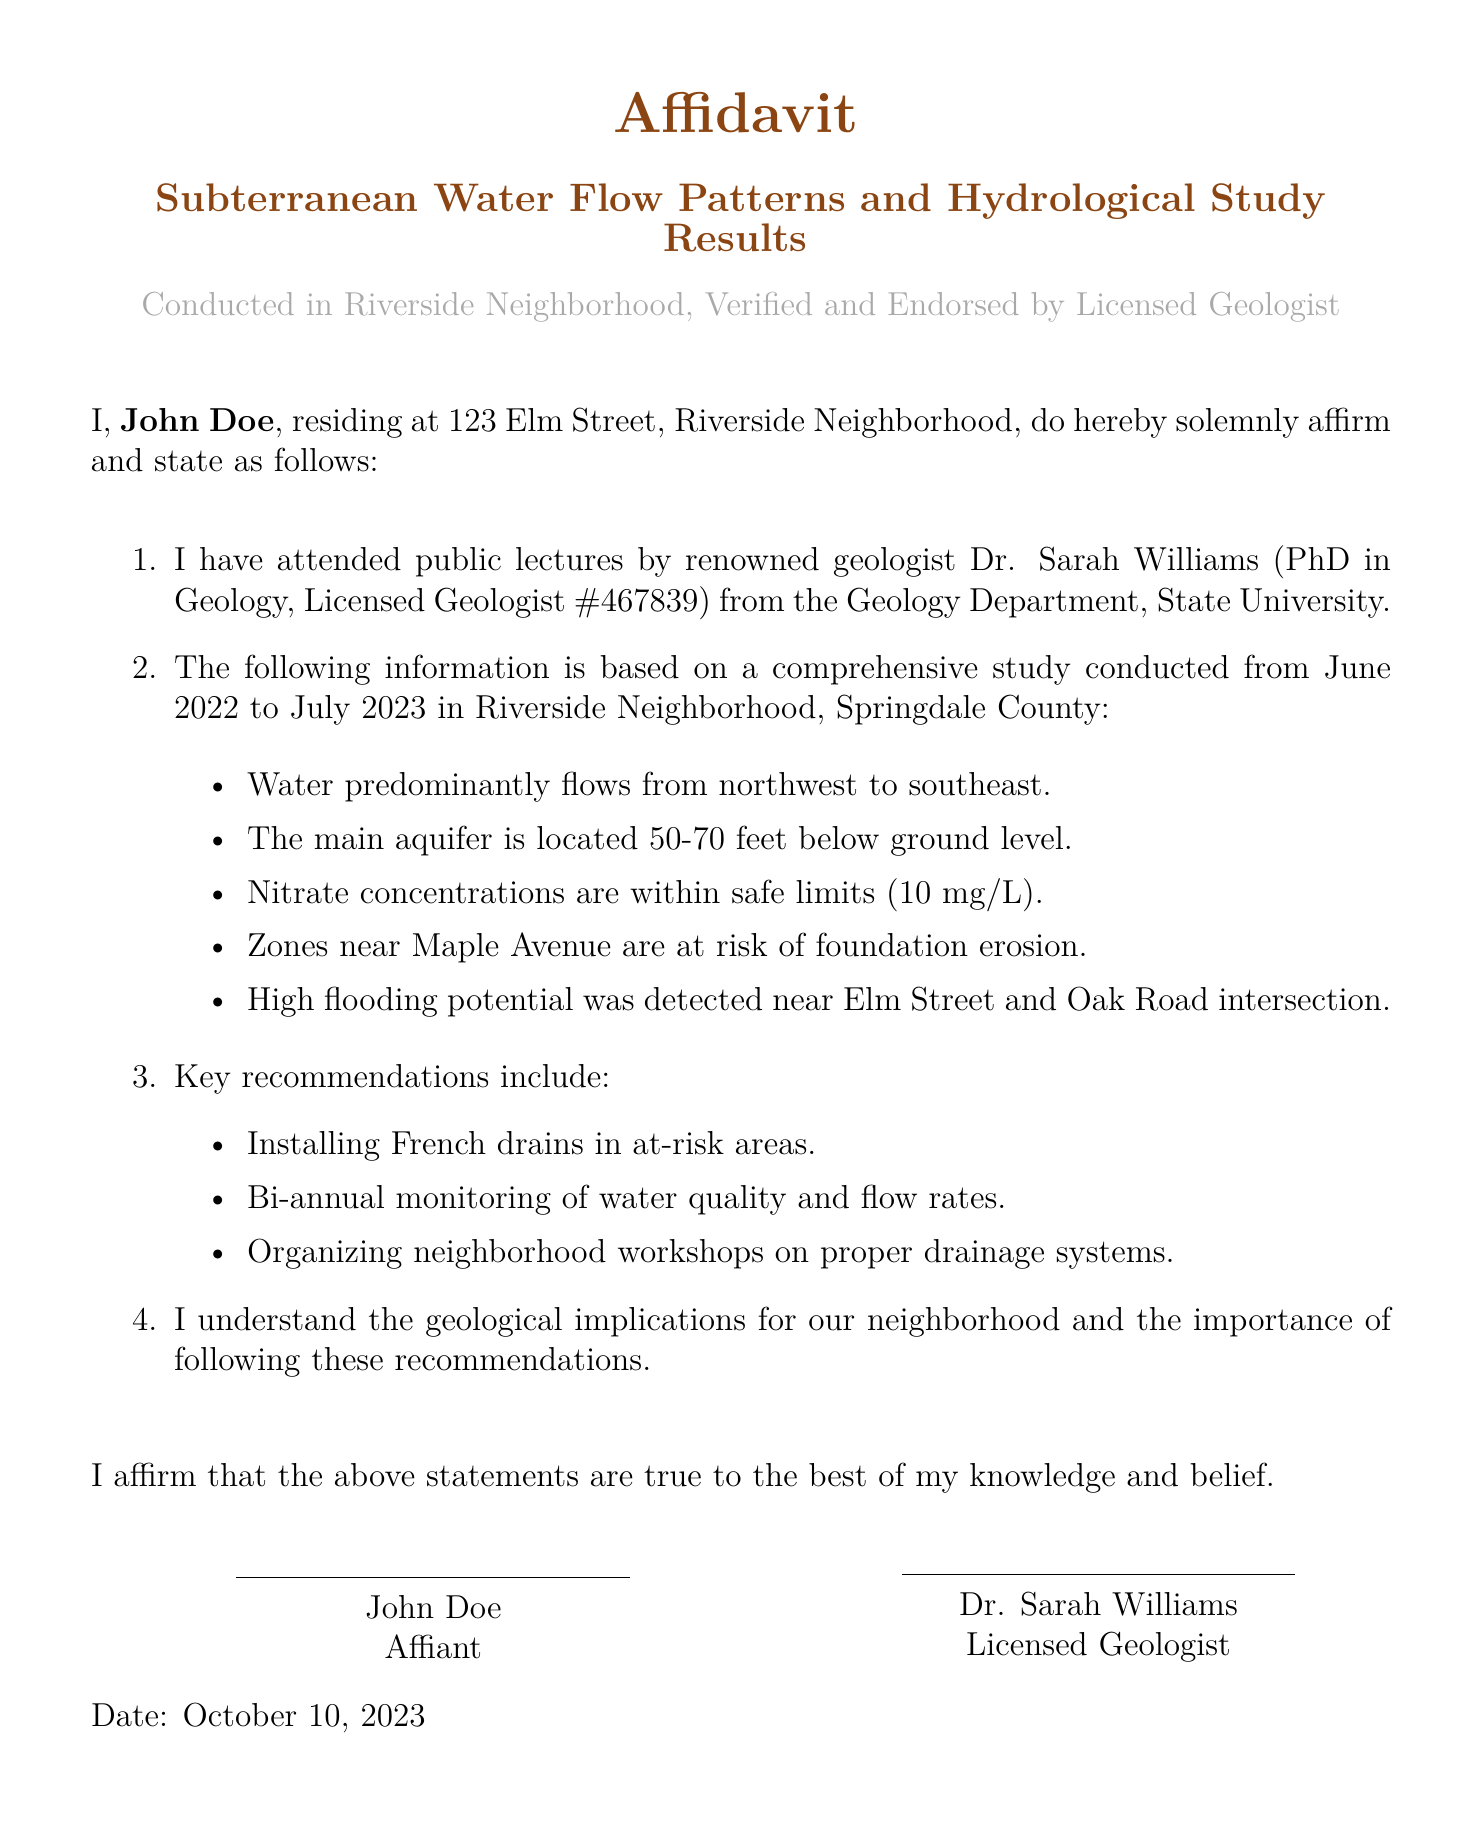What is the name of the licensed geologist? The licensed geologist's name is mentioned in the document as Dr. Sarah Williams.
Answer: Dr. Sarah Williams What is the range of the main aquifer's depth? The depth of the main aquifer is specified as being between 50 to 70 feet below ground level.
Answer: 50-70 feet When was the study conducted? The document states that the study was conducted from June 2022 to July 2023, providing specific dates for the study period.
Answer: June 2022 to July 2023 What is the maximum safe limit for nitrate concentrations mentioned? The document lists that nitrate concentrations should be within safe limits, specifically mentioning a maximum of 10 mg/L.
Answer: ≤10 mg/L Where is the high flooding potential detected? The document states that high flooding potential was detected near the intersection of Elm Street and Oak Road.
Answer: Elm Street and Oak Road intersection What key recommendation is made for at-risk areas? The document includes recommendations specifically mentioning the installation of French drains in areas identified as at risk.
Answer: Installing French drains What is the purpose of the neighborhood workshops? The document recommends organizing workshops to educate residents on proper drainage systems, indicating a focus on community education and involvement.
Answer: Proper drainage systems Who is the affiant? The document identifies the affiant as John Doe, who resides in the Riverside Neighborhood, confirming his role in the affidavit.
Answer: John Doe 